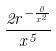<formula> <loc_0><loc_0><loc_500><loc_500>\frac { 2 r ^ { - \frac { 0 } { x ^ { 2 } } } } { x ^ { 5 } }</formula> 